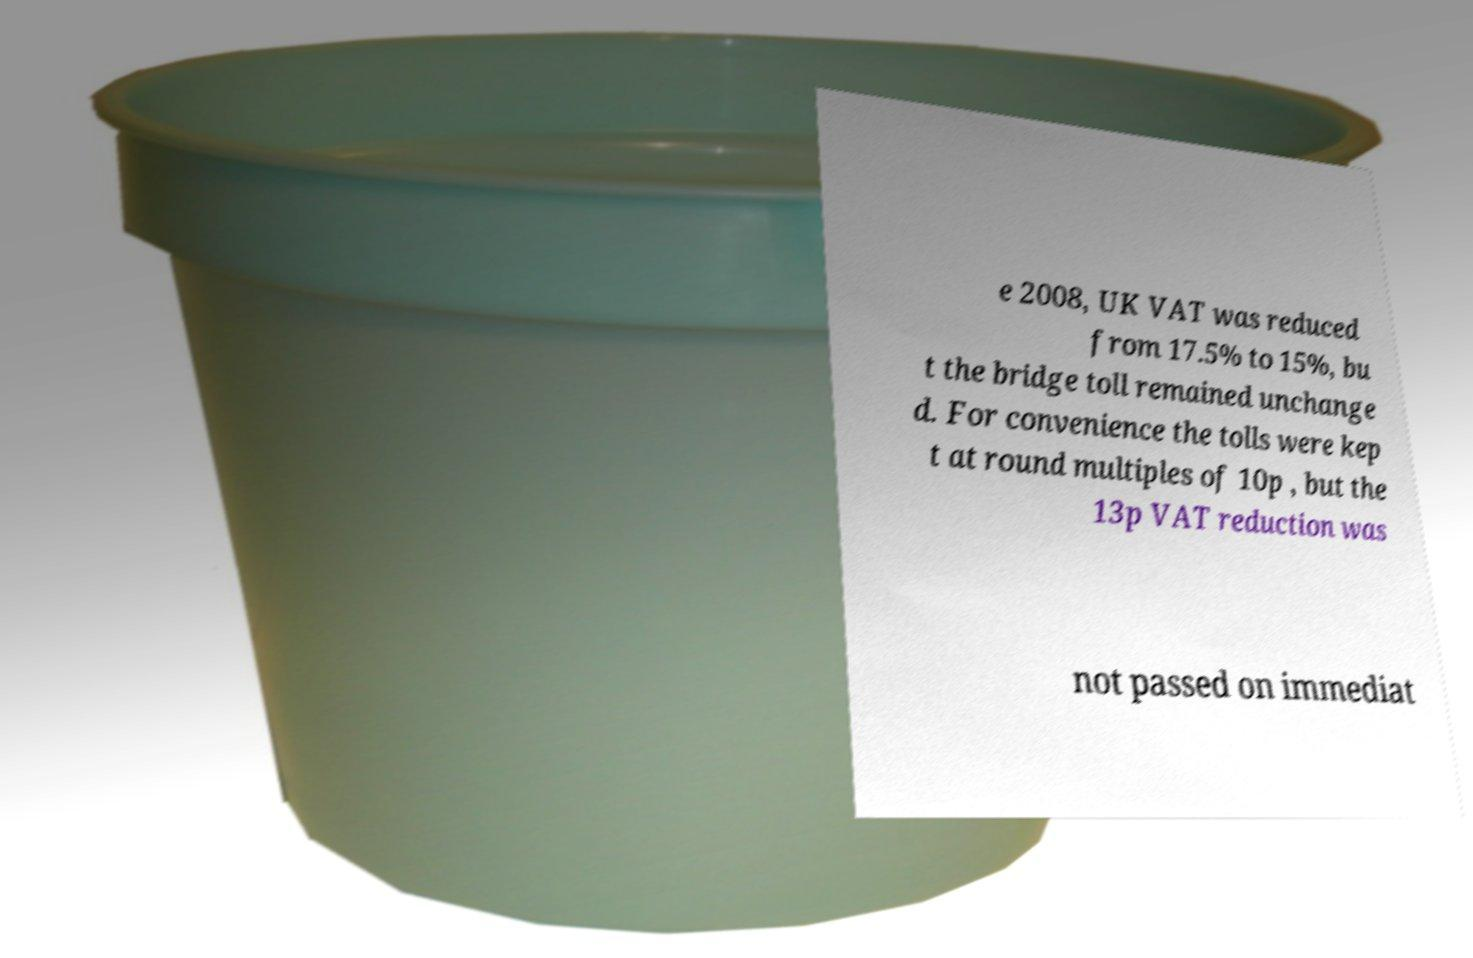Please identify and transcribe the text found in this image. e 2008, UK VAT was reduced from 17.5% to 15%, bu t the bridge toll remained unchange d. For convenience the tolls were kep t at round multiples of 10p , but the 13p VAT reduction was not passed on immediat 